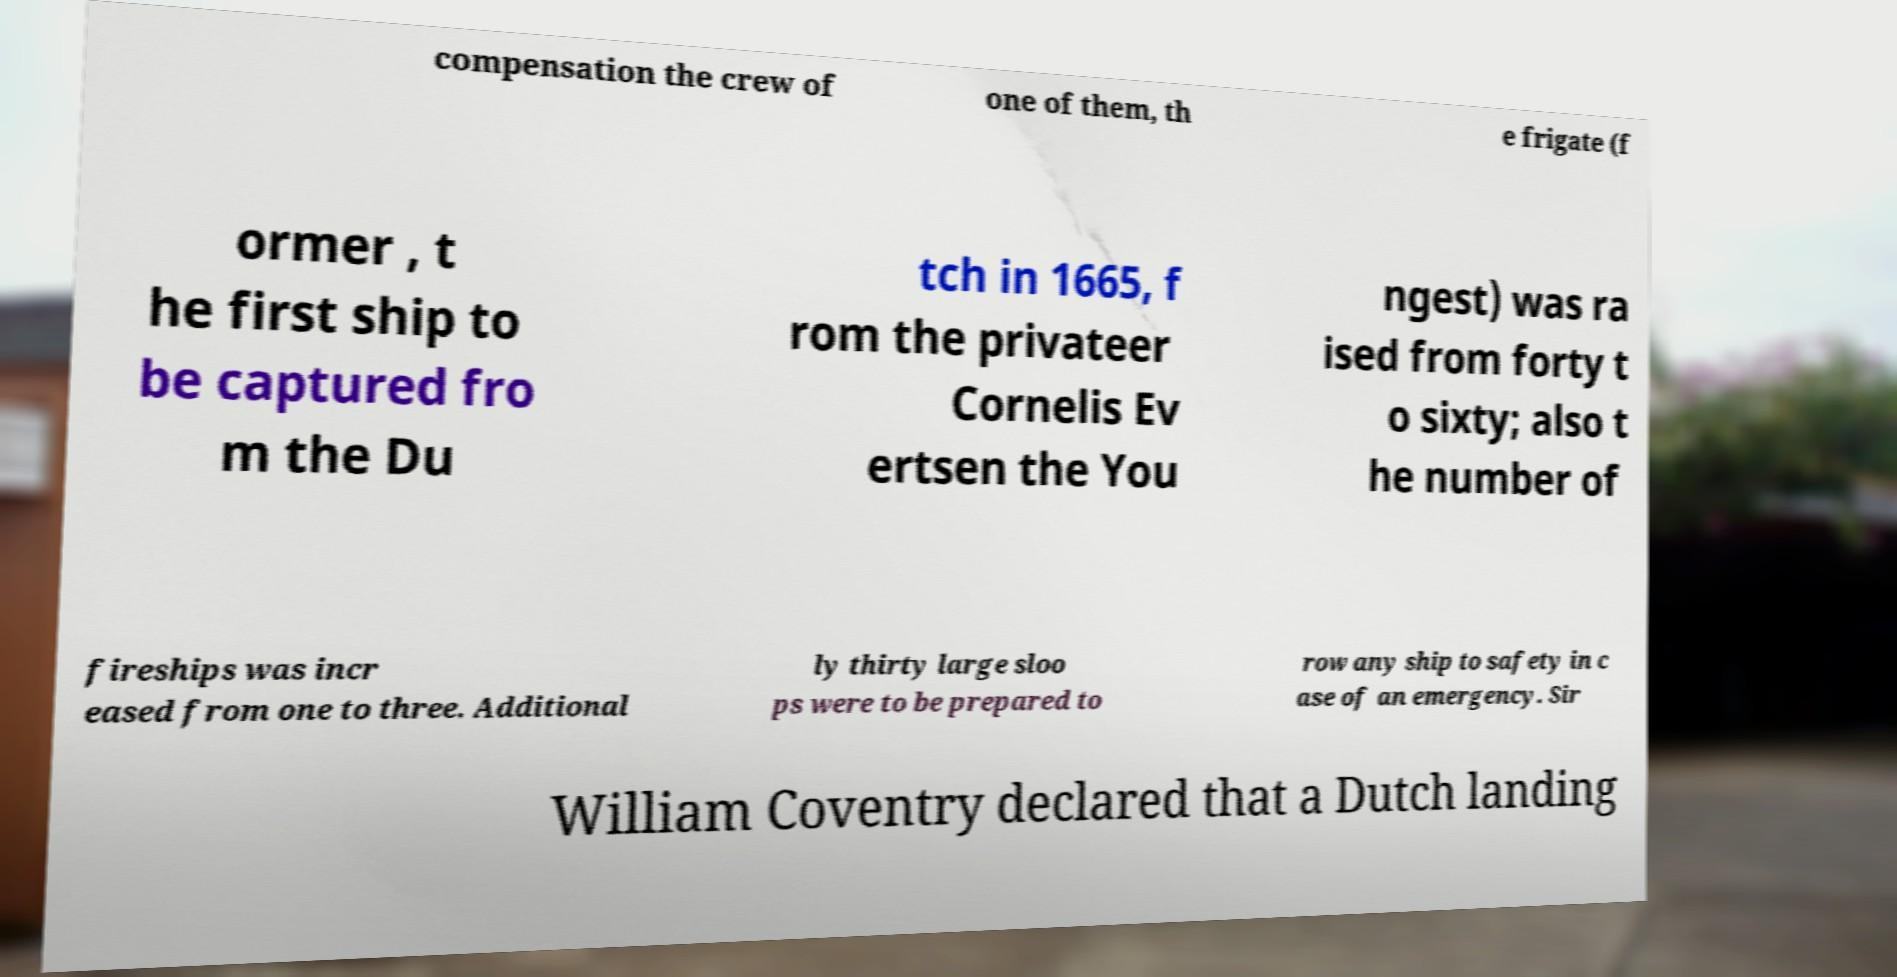I need the written content from this picture converted into text. Can you do that? compensation the crew of one of them, th e frigate (f ormer , t he first ship to be captured fro m the Du tch in 1665, f rom the privateer Cornelis Ev ertsen the You ngest) was ra ised from forty t o sixty; also t he number of fireships was incr eased from one to three. Additional ly thirty large sloo ps were to be prepared to row any ship to safety in c ase of an emergency. Sir William Coventry declared that a Dutch landing 